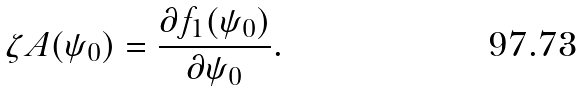Convert formula to latex. <formula><loc_0><loc_0><loc_500><loc_500>\zeta A ( \psi _ { 0 } ) = \frac { \partial f _ { 1 } ( \psi _ { 0 } ) } { \partial \psi _ { 0 } } .</formula> 